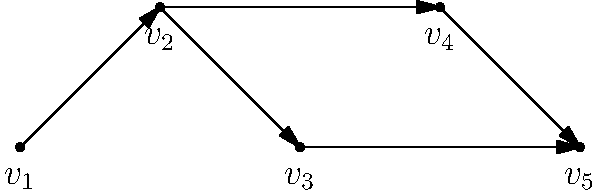Given the directed graph representing data dependencies in a program slice, what is the minimum number of vertices that need to be removed to make the graph acyclic? To determine the minimum number of vertices to remove to make the graph acyclic, we need to analyze the graph structure:

1. First, identify any cycles in the graph:
   - There are no cycles visible in this graph.

2. Check for directed paths:
   - The graph shows directed paths from $v_1$ to $v_5$ through two routes:
     a) $v_1 \rightarrow v_2 \rightarrow v_5$
     b) $v_1 \rightarrow v_4 \rightarrow v_5$

3. Analyze the graph's topology:
   - The graph is already a Directed Acyclic Graph (DAG).
   - It represents a valid topological ordering of dependencies.

4. Conclusion:
   - Since the graph is already acyclic, no vertices need to be removed.

Therefore, the minimum number of vertices that need to be removed to make the graph acyclic is 0.
Answer: 0 